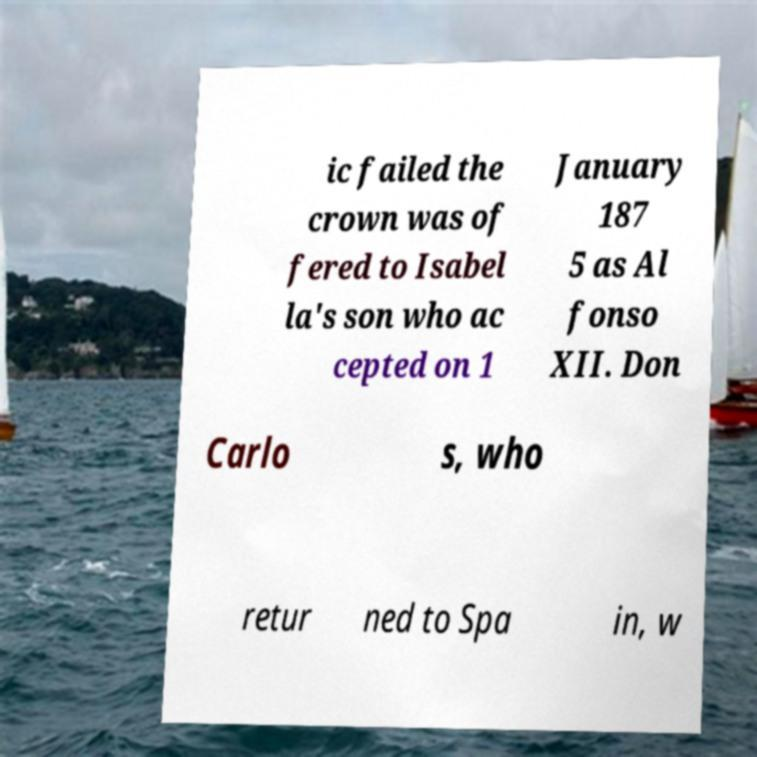Could you assist in decoding the text presented in this image and type it out clearly? ic failed the crown was of fered to Isabel la's son who ac cepted on 1 January 187 5 as Al fonso XII. Don Carlo s, who retur ned to Spa in, w 